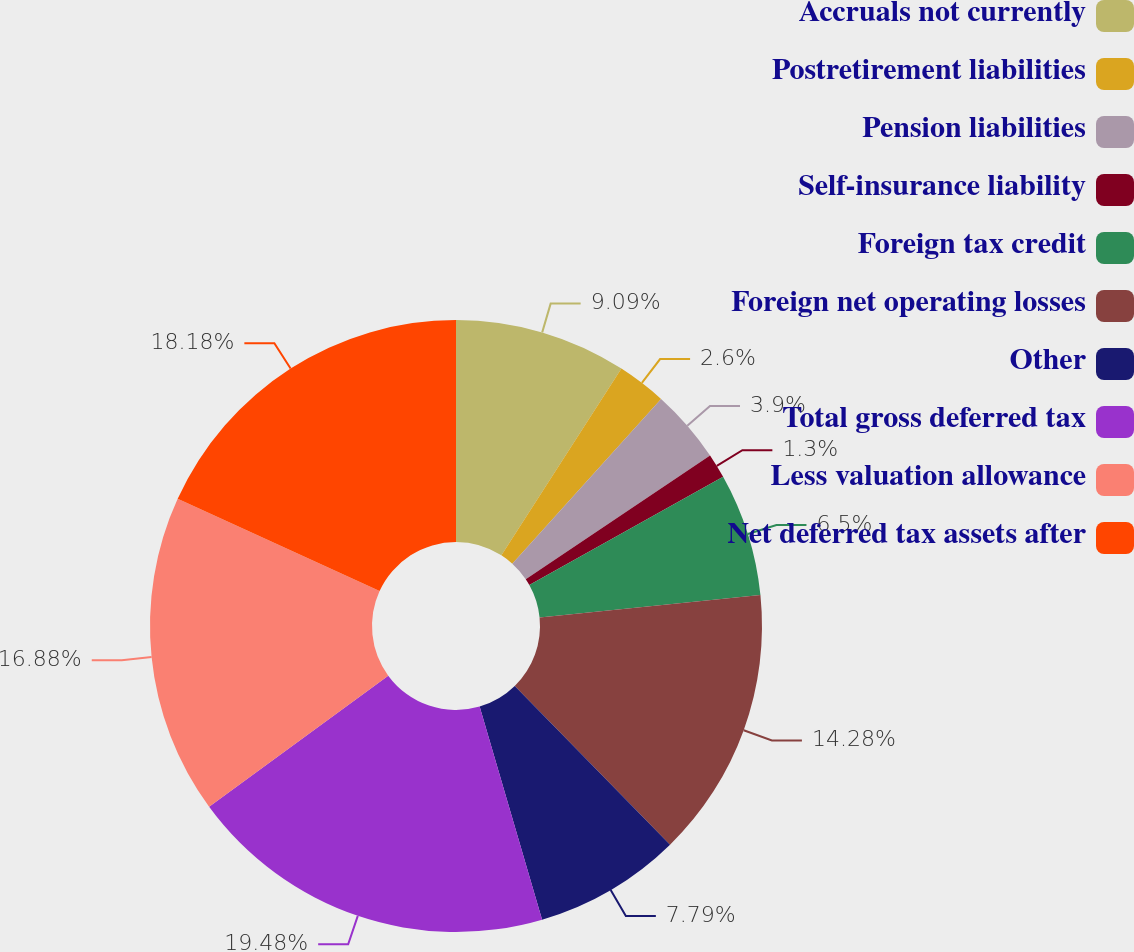<chart> <loc_0><loc_0><loc_500><loc_500><pie_chart><fcel>Accruals not currently<fcel>Postretirement liabilities<fcel>Pension liabilities<fcel>Self-insurance liability<fcel>Foreign tax credit<fcel>Foreign net operating losses<fcel>Other<fcel>Total gross deferred tax<fcel>Less valuation allowance<fcel>Net deferred tax assets after<nl><fcel>9.09%<fcel>2.6%<fcel>3.9%<fcel>1.3%<fcel>6.5%<fcel>14.28%<fcel>7.79%<fcel>19.48%<fcel>16.88%<fcel>18.18%<nl></chart> 